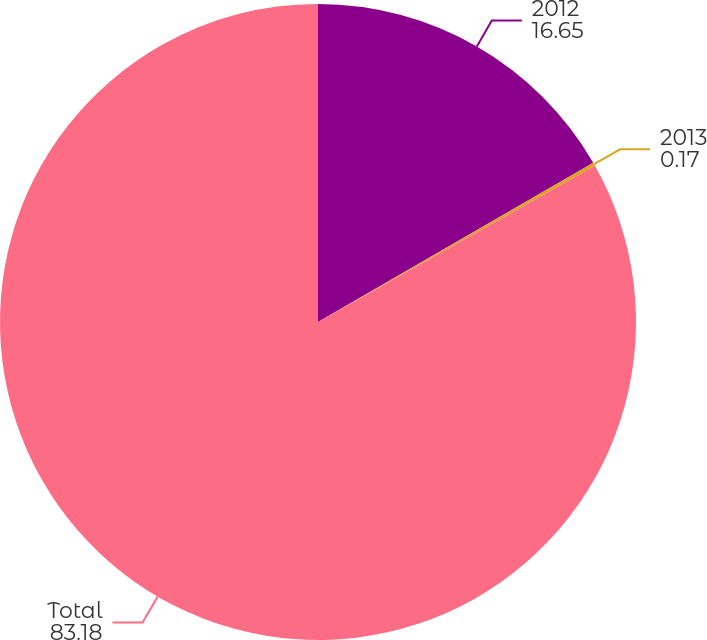Convert chart to OTSL. <chart><loc_0><loc_0><loc_500><loc_500><pie_chart><fcel>2012<fcel>2013<fcel>Total<nl><fcel>16.65%<fcel>0.17%<fcel>83.18%<nl></chart> 